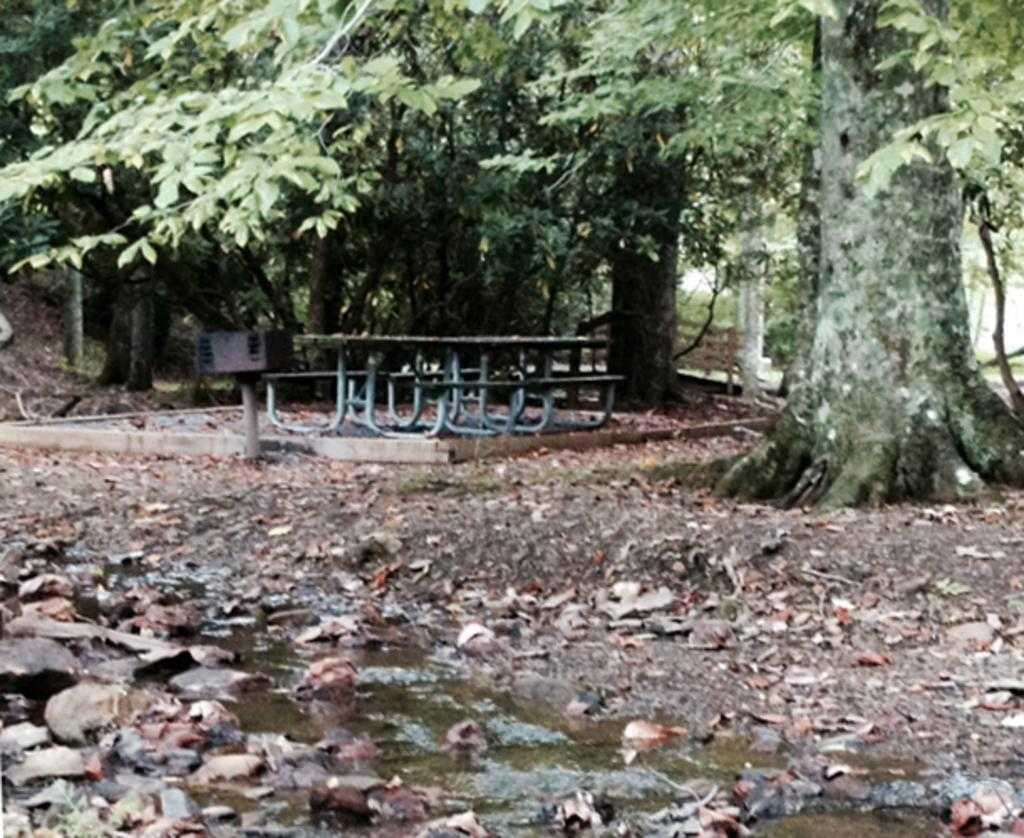What is located on the left side of the image? There is water and stones on the ground on the left side of the image. What can be seen in the background of the image? There are trees, benches, and a table in the background of the image. What is present on the ground in the background of the image? Dry leaves are present on the ground in the background of the image. What type of texture does the tree in the image have? There is no tree present in the image; only water, stones, trees, benches, a table, and dry leaves are visible. What is the fork used for in the image? There is no fork present in the image. 